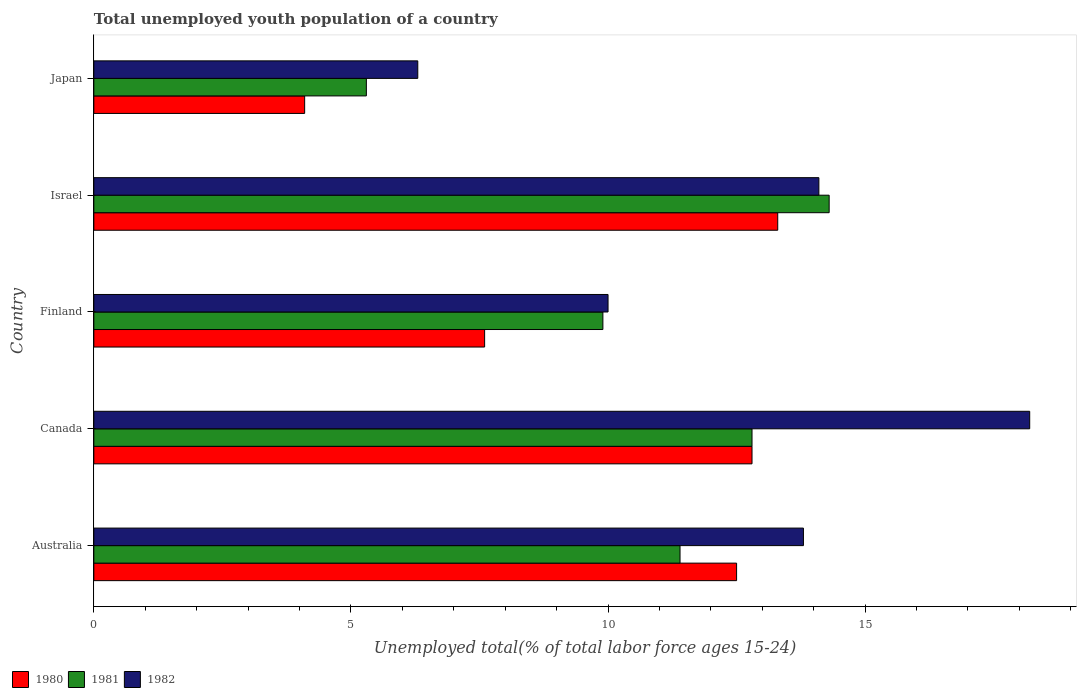Are the number of bars on each tick of the Y-axis equal?
Your answer should be compact. Yes. How many bars are there on the 3rd tick from the top?
Your answer should be very brief. 3. What is the percentage of total unemployed youth population of a country in 1980 in Finland?
Make the answer very short. 7.6. Across all countries, what is the maximum percentage of total unemployed youth population of a country in 1980?
Provide a short and direct response. 13.3. Across all countries, what is the minimum percentage of total unemployed youth population of a country in 1981?
Provide a short and direct response. 5.3. What is the total percentage of total unemployed youth population of a country in 1980 in the graph?
Your response must be concise. 50.3. What is the difference between the percentage of total unemployed youth population of a country in 1980 in Finland and that in Israel?
Provide a short and direct response. -5.7. What is the difference between the percentage of total unemployed youth population of a country in 1982 in Japan and the percentage of total unemployed youth population of a country in 1981 in Australia?
Ensure brevity in your answer.  -5.1. What is the average percentage of total unemployed youth population of a country in 1980 per country?
Offer a very short reply. 10.06. What is the difference between the percentage of total unemployed youth population of a country in 1982 and percentage of total unemployed youth population of a country in 1980 in Canada?
Provide a short and direct response. 5.4. What is the ratio of the percentage of total unemployed youth population of a country in 1981 in Australia to that in Canada?
Make the answer very short. 0.89. Is the percentage of total unemployed youth population of a country in 1982 in Australia less than that in Israel?
Make the answer very short. Yes. Is the difference between the percentage of total unemployed youth population of a country in 1982 in Australia and Canada greater than the difference between the percentage of total unemployed youth population of a country in 1980 in Australia and Canada?
Give a very brief answer. No. What is the difference between the highest and the second highest percentage of total unemployed youth population of a country in 1982?
Keep it short and to the point. 4.1. What is the difference between the highest and the lowest percentage of total unemployed youth population of a country in 1982?
Make the answer very short. 11.9. Is the sum of the percentage of total unemployed youth population of a country in 1981 in Canada and Israel greater than the maximum percentage of total unemployed youth population of a country in 1980 across all countries?
Offer a very short reply. Yes. What does the 3rd bar from the bottom in Australia represents?
Provide a short and direct response. 1982. Is it the case that in every country, the sum of the percentage of total unemployed youth population of a country in 1980 and percentage of total unemployed youth population of a country in 1981 is greater than the percentage of total unemployed youth population of a country in 1982?
Your response must be concise. Yes. How many bars are there?
Offer a terse response. 15. Are all the bars in the graph horizontal?
Provide a short and direct response. Yes. How many countries are there in the graph?
Ensure brevity in your answer.  5. What is the difference between two consecutive major ticks on the X-axis?
Keep it short and to the point. 5. Does the graph contain any zero values?
Make the answer very short. No. Does the graph contain grids?
Make the answer very short. No. Where does the legend appear in the graph?
Your response must be concise. Bottom left. How many legend labels are there?
Provide a succinct answer. 3. How are the legend labels stacked?
Provide a succinct answer. Horizontal. What is the title of the graph?
Give a very brief answer. Total unemployed youth population of a country. What is the label or title of the X-axis?
Your answer should be very brief. Unemployed total(% of total labor force ages 15-24). What is the label or title of the Y-axis?
Provide a short and direct response. Country. What is the Unemployed total(% of total labor force ages 15-24) in 1981 in Australia?
Offer a very short reply. 11.4. What is the Unemployed total(% of total labor force ages 15-24) of 1982 in Australia?
Your answer should be very brief. 13.8. What is the Unemployed total(% of total labor force ages 15-24) in 1980 in Canada?
Make the answer very short. 12.8. What is the Unemployed total(% of total labor force ages 15-24) in 1981 in Canada?
Offer a terse response. 12.8. What is the Unemployed total(% of total labor force ages 15-24) in 1982 in Canada?
Your response must be concise. 18.2. What is the Unemployed total(% of total labor force ages 15-24) of 1980 in Finland?
Keep it short and to the point. 7.6. What is the Unemployed total(% of total labor force ages 15-24) in 1981 in Finland?
Offer a very short reply. 9.9. What is the Unemployed total(% of total labor force ages 15-24) in 1982 in Finland?
Offer a terse response. 10. What is the Unemployed total(% of total labor force ages 15-24) in 1980 in Israel?
Provide a short and direct response. 13.3. What is the Unemployed total(% of total labor force ages 15-24) in 1981 in Israel?
Provide a succinct answer. 14.3. What is the Unemployed total(% of total labor force ages 15-24) of 1982 in Israel?
Make the answer very short. 14.1. What is the Unemployed total(% of total labor force ages 15-24) in 1980 in Japan?
Give a very brief answer. 4.1. What is the Unemployed total(% of total labor force ages 15-24) in 1981 in Japan?
Keep it short and to the point. 5.3. What is the Unemployed total(% of total labor force ages 15-24) in 1982 in Japan?
Provide a short and direct response. 6.3. Across all countries, what is the maximum Unemployed total(% of total labor force ages 15-24) of 1980?
Make the answer very short. 13.3. Across all countries, what is the maximum Unemployed total(% of total labor force ages 15-24) of 1981?
Ensure brevity in your answer.  14.3. Across all countries, what is the maximum Unemployed total(% of total labor force ages 15-24) in 1982?
Ensure brevity in your answer.  18.2. Across all countries, what is the minimum Unemployed total(% of total labor force ages 15-24) of 1980?
Your answer should be compact. 4.1. Across all countries, what is the minimum Unemployed total(% of total labor force ages 15-24) of 1981?
Make the answer very short. 5.3. Across all countries, what is the minimum Unemployed total(% of total labor force ages 15-24) in 1982?
Make the answer very short. 6.3. What is the total Unemployed total(% of total labor force ages 15-24) in 1980 in the graph?
Give a very brief answer. 50.3. What is the total Unemployed total(% of total labor force ages 15-24) in 1981 in the graph?
Give a very brief answer. 53.7. What is the total Unemployed total(% of total labor force ages 15-24) in 1982 in the graph?
Provide a short and direct response. 62.4. What is the difference between the Unemployed total(% of total labor force ages 15-24) of 1981 in Australia and that in Canada?
Ensure brevity in your answer.  -1.4. What is the difference between the Unemployed total(% of total labor force ages 15-24) in 1980 in Australia and that in Finland?
Offer a terse response. 4.9. What is the difference between the Unemployed total(% of total labor force ages 15-24) of 1981 in Australia and that in Finland?
Offer a very short reply. 1.5. What is the difference between the Unemployed total(% of total labor force ages 15-24) in 1980 in Australia and that in Israel?
Keep it short and to the point. -0.8. What is the difference between the Unemployed total(% of total labor force ages 15-24) in 1982 in Australia and that in Israel?
Provide a short and direct response. -0.3. What is the difference between the Unemployed total(% of total labor force ages 15-24) of 1980 in Australia and that in Japan?
Provide a succinct answer. 8.4. What is the difference between the Unemployed total(% of total labor force ages 15-24) of 1981 in Australia and that in Japan?
Keep it short and to the point. 6.1. What is the difference between the Unemployed total(% of total labor force ages 15-24) in 1981 in Canada and that in Finland?
Make the answer very short. 2.9. What is the difference between the Unemployed total(% of total labor force ages 15-24) in 1982 in Canada and that in Israel?
Provide a succinct answer. 4.1. What is the difference between the Unemployed total(% of total labor force ages 15-24) of 1980 in Canada and that in Japan?
Ensure brevity in your answer.  8.7. What is the difference between the Unemployed total(% of total labor force ages 15-24) of 1981 in Canada and that in Japan?
Provide a succinct answer. 7.5. What is the difference between the Unemployed total(% of total labor force ages 15-24) in 1981 in Finland and that in Israel?
Your response must be concise. -4.4. What is the difference between the Unemployed total(% of total labor force ages 15-24) in 1980 in Finland and that in Japan?
Offer a very short reply. 3.5. What is the difference between the Unemployed total(% of total labor force ages 15-24) in 1980 in Israel and that in Japan?
Give a very brief answer. 9.2. What is the difference between the Unemployed total(% of total labor force ages 15-24) of 1981 in Israel and that in Japan?
Provide a short and direct response. 9. What is the difference between the Unemployed total(% of total labor force ages 15-24) in 1980 in Australia and the Unemployed total(% of total labor force ages 15-24) in 1982 in Canada?
Offer a very short reply. -5.7. What is the difference between the Unemployed total(% of total labor force ages 15-24) in 1981 in Australia and the Unemployed total(% of total labor force ages 15-24) in 1982 in Canada?
Make the answer very short. -6.8. What is the difference between the Unemployed total(% of total labor force ages 15-24) in 1980 in Australia and the Unemployed total(% of total labor force ages 15-24) in 1981 in Israel?
Make the answer very short. -1.8. What is the difference between the Unemployed total(% of total labor force ages 15-24) of 1980 in Australia and the Unemployed total(% of total labor force ages 15-24) of 1982 in Israel?
Give a very brief answer. -1.6. What is the difference between the Unemployed total(% of total labor force ages 15-24) of 1980 in Australia and the Unemployed total(% of total labor force ages 15-24) of 1981 in Japan?
Offer a terse response. 7.2. What is the difference between the Unemployed total(% of total labor force ages 15-24) in 1980 in Australia and the Unemployed total(% of total labor force ages 15-24) in 1982 in Japan?
Your answer should be very brief. 6.2. What is the difference between the Unemployed total(% of total labor force ages 15-24) of 1980 in Canada and the Unemployed total(% of total labor force ages 15-24) of 1981 in Finland?
Give a very brief answer. 2.9. What is the difference between the Unemployed total(% of total labor force ages 15-24) of 1980 in Canada and the Unemployed total(% of total labor force ages 15-24) of 1982 in Finland?
Provide a short and direct response. 2.8. What is the difference between the Unemployed total(% of total labor force ages 15-24) of 1980 in Canada and the Unemployed total(% of total labor force ages 15-24) of 1981 in Israel?
Make the answer very short. -1.5. What is the difference between the Unemployed total(% of total labor force ages 15-24) in 1980 in Canada and the Unemployed total(% of total labor force ages 15-24) in 1982 in Israel?
Give a very brief answer. -1.3. What is the difference between the Unemployed total(% of total labor force ages 15-24) of 1981 in Canada and the Unemployed total(% of total labor force ages 15-24) of 1982 in Israel?
Your answer should be very brief. -1.3. What is the difference between the Unemployed total(% of total labor force ages 15-24) of 1980 in Canada and the Unemployed total(% of total labor force ages 15-24) of 1981 in Japan?
Your response must be concise. 7.5. What is the difference between the Unemployed total(% of total labor force ages 15-24) in 1980 in Finland and the Unemployed total(% of total labor force ages 15-24) in 1981 in Israel?
Your response must be concise. -6.7. What is the difference between the Unemployed total(% of total labor force ages 15-24) in 1980 in Finland and the Unemployed total(% of total labor force ages 15-24) in 1982 in Israel?
Your answer should be very brief. -6.5. What is the difference between the Unemployed total(% of total labor force ages 15-24) of 1980 in Finland and the Unemployed total(% of total labor force ages 15-24) of 1981 in Japan?
Your response must be concise. 2.3. What is the difference between the Unemployed total(% of total labor force ages 15-24) of 1981 in Finland and the Unemployed total(% of total labor force ages 15-24) of 1982 in Japan?
Provide a short and direct response. 3.6. What is the difference between the Unemployed total(% of total labor force ages 15-24) of 1980 in Israel and the Unemployed total(% of total labor force ages 15-24) of 1981 in Japan?
Give a very brief answer. 8. What is the average Unemployed total(% of total labor force ages 15-24) in 1980 per country?
Make the answer very short. 10.06. What is the average Unemployed total(% of total labor force ages 15-24) of 1981 per country?
Offer a terse response. 10.74. What is the average Unemployed total(% of total labor force ages 15-24) in 1982 per country?
Your answer should be compact. 12.48. What is the difference between the Unemployed total(% of total labor force ages 15-24) of 1980 and Unemployed total(% of total labor force ages 15-24) of 1981 in Australia?
Keep it short and to the point. 1.1. What is the difference between the Unemployed total(% of total labor force ages 15-24) of 1981 and Unemployed total(% of total labor force ages 15-24) of 1982 in Australia?
Your answer should be very brief. -2.4. What is the difference between the Unemployed total(% of total labor force ages 15-24) in 1980 and Unemployed total(% of total labor force ages 15-24) in 1981 in Finland?
Offer a terse response. -2.3. What is the difference between the Unemployed total(% of total labor force ages 15-24) of 1980 and Unemployed total(% of total labor force ages 15-24) of 1982 in Finland?
Ensure brevity in your answer.  -2.4. What is the difference between the Unemployed total(% of total labor force ages 15-24) in 1981 and Unemployed total(% of total labor force ages 15-24) in 1982 in Finland?
Offer a very short reply. -0.1. What is the difference between the Unemployed total(% of total labor force ages 15-24) in 1980 and Unemployed total(% of total labor force ages 15-24) in 1982 in Israel?
Provide a succinct answer. -0.8. What is the difference between the Unemployed total(% of total labor force ages 15-24) in 1981 and Unemployed total(% of total labor force ages 15-24) in 1982 in Israel?
Your response must be concise. 0.2. What is the difference between the Unemployed total(% of total labor force ages 15-24) in 1980 and Unemployed total(% of total labor force ages 15-24) in 1982 in Japan?
Offer a terse response. -2.2. What is the ratio of the Unemployed total(% of total labor force ages 15-24) of 1980 in Australia to that in Canada?
Your response must be concise. 0.98. What is the ratio of the Unemployed total(% of total labor force ages 15-24) in 1981 in Australia to that in Canada?
Your response must be concise. 0.89. What is the ratio of the Unemployed total(% of total labor force ages 15-24) of 1982 in Australia to that in Canada?
Ensure brevity in your answer.  0.76. What is the ratio of the Unemployed total(% of total labor force ages 15-24) of 1980 in Australia to that in Finland?
Ensure brevity in your answer.  1.64. What is the ratio of the Unemployed total(% of total labor force ages 15-24) in 1981 in Australia to that in Finland?
Your answer should be compact. 1.15. What is the ratio of the Unemployed total(% of total labor force ages 15-24) of 1982 in Australia to that in Finland?
Offer a terse response. 1.38. What is the ratio of the Unemployed total(% of total labor force ages 15-24) in 1980 in Australia to that in Israel?
Make the answer very short. 0.94. What is the ratio of the Unemployed total(% of total labor force ages 15-24) of 1981 in Australia to that in Israel?
Your answer should be very brief. 0.8. What is the ratio of the Unemployed total(% of total labor force ages 15-24) of 1982 in Australia to that in Israel?
Keep it short and to the point. 0.98. What is the ratio of the Unemployed total(% of total labor force ages 15-24) of 1980 in Australia to that in Japan?
Offer a terse response. 3.05. What is the ratio of the Unemployed total(% of total labor force ages 15-24) in 1981 in Australia to that in Japan?
Offer a terse response. 2.15. What is the ratio of the Unemployed total(% of total labor force ages 15-24) of 1982 in Australia to that in Japan?
Your response must be concise. 2.19. What is the ratio of the Unemployed total(% of total labor force ages 15-24) in 1980 in Canada to that in Finland?
Make the answer very short. 1.68. What is the ratio of the Unemployed total(% of total labor force ages 15-24) in 1981 in Canada to that in Finland?
Provide a short and direct response. 1.29. What is the ratio of the Unemployed total(% of total labor force ages 15-24) of 1982 in Canada to that in Finland?
Give a very brief answer. 1.82. What is the ratio of the Unemployed total(% of total labor force ages 15-24) in 1980 in Canada to that in Israel?
Ensure brevity in your answer.  0.96. What is the ratio of the Unemployed total(% of total labor force ages 15-24) of 1981 in Canada to that in Israel?
Your answer should be very brief. 0.9. What is the ratio of the Unemployed total(% of total labor force ages 15-24) of 1982 in Canada to that in Israel?
Make the answer very short. 1.29. What is the ratio of the Unemployed total(% of total labor force ages 15-24) of 1980 in Canada to that in Japan?
Provide a short and direct response. 3.12. What is the ratio of the Unemployed total(% of total labor force ages 15-24) in 1981 in Canada to that in Japan?
Give a very brief answer. 2.42. What is the ratio of the Unemployed total(% of total labor force ages 15-24) in 1982 in Canada to that in Japan?
Keep it short and to the point. 2.89. What is the ratio of the Unemployed total(% of total labor force ages 15-24) in 1981 in Finland to that in Israel?
Your answer should be very brief. 0.69. What is the ratio of the Unemployed total(% of total labor force ages 15-24) of 1982 in Finland to that in Israel?
Make the answer very short. 0.71. What is the ratio of the Unemployed total(% of total labor force ages 15-24) in 1980 in Finland to that in Japan?
Keep it short and to the point. 1.85. What is the ratio of the Unemployed total(% of total labor force ages 15-24) in 1981 in Finland to that in Japan?
Give a very brief answer. 1.87. What is the ratio of the Unemployed total(% of total labor force ages 15-24) of 1982 in Finland to that in Japan?
Provide a succinct answer. 1.59. What is the ratio of the Unemployed total(% of total labor force ages 15-24) in 1980 in Israel to that in Japan?
Your response must be concise. 3.24. What is the ratio of the Unemployed total(% of total labor force ages 15-24) of 1981 in Israel to that in Japan?
Your answer should be very brief. 2.7. What is the ratio of the Unemployed total(% of total labor force ages 15-24) of 1982 in Israel to that in Japan?
Keep it short and to the point. 2.24. What is the difference between the highest and the second highest Unemployed total(% of total labor force ages 15-24) in 1980?
Keep it short and to the point. 0.5. What is the difference between the highest and the second highest Unemployed total(% of total labor force ages 15-24) of 1981?
Provide a short and direct response. 1.5. What is the difference between the highest and the second highest Unemployed total(% of total labor force ages 15-24) in 1982?
Ensure brevity in your answer.  4.1. What is the difference between the highest and the lowest Unemployed total(% of total labor force ages 15-24) in 1981?
Make the answer very short. 9. 